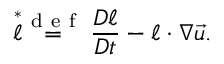Convert formula to latex. <formula><loc_0><loc_0><loc_500><loc_500>\stackrel { * } { \ell } \stackrel { d e f } { = } \frac { D \ell } { D t } - \ell \cdot \nabla \vec { u } .</formula> 